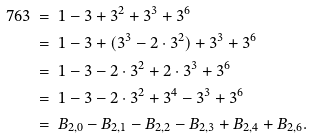<formula> <loc_0><loc_0><loc_500><loc_500>7 6 3 & \ = \ 1 - 3 + 3 ^ { 2 } + 3 ^ { 3 } + 3 ^ { 6 } \\ & \ = \ 1 - 3 + ( 3 ^ { 3 } - 2 \cdot 3 ^ { 2 } ) + 3 ^ { 3 } + 3 ^ { 6 } \\ & \ = \ 1 - 3 - 2 \cdot 3 ^ { 2 } + 2 \cdot 3 ^ { 3 } + 3 ^ { 6 } \\ & \ = \ 1 - 3 - 2 \cdot 3 ^ { 2 } + 3 ^ { 4 } - 3 ^ { 3 } + 3 ^ { 6 } \\ & \ = \ B _ { 2 , 0 } - B _ { 2 , 1 } - B _ { 2 , 2 } - B _ { 2 , 3 } + B _ { 2 , 4 } + B _ { 2 , 6 } .</formula> 